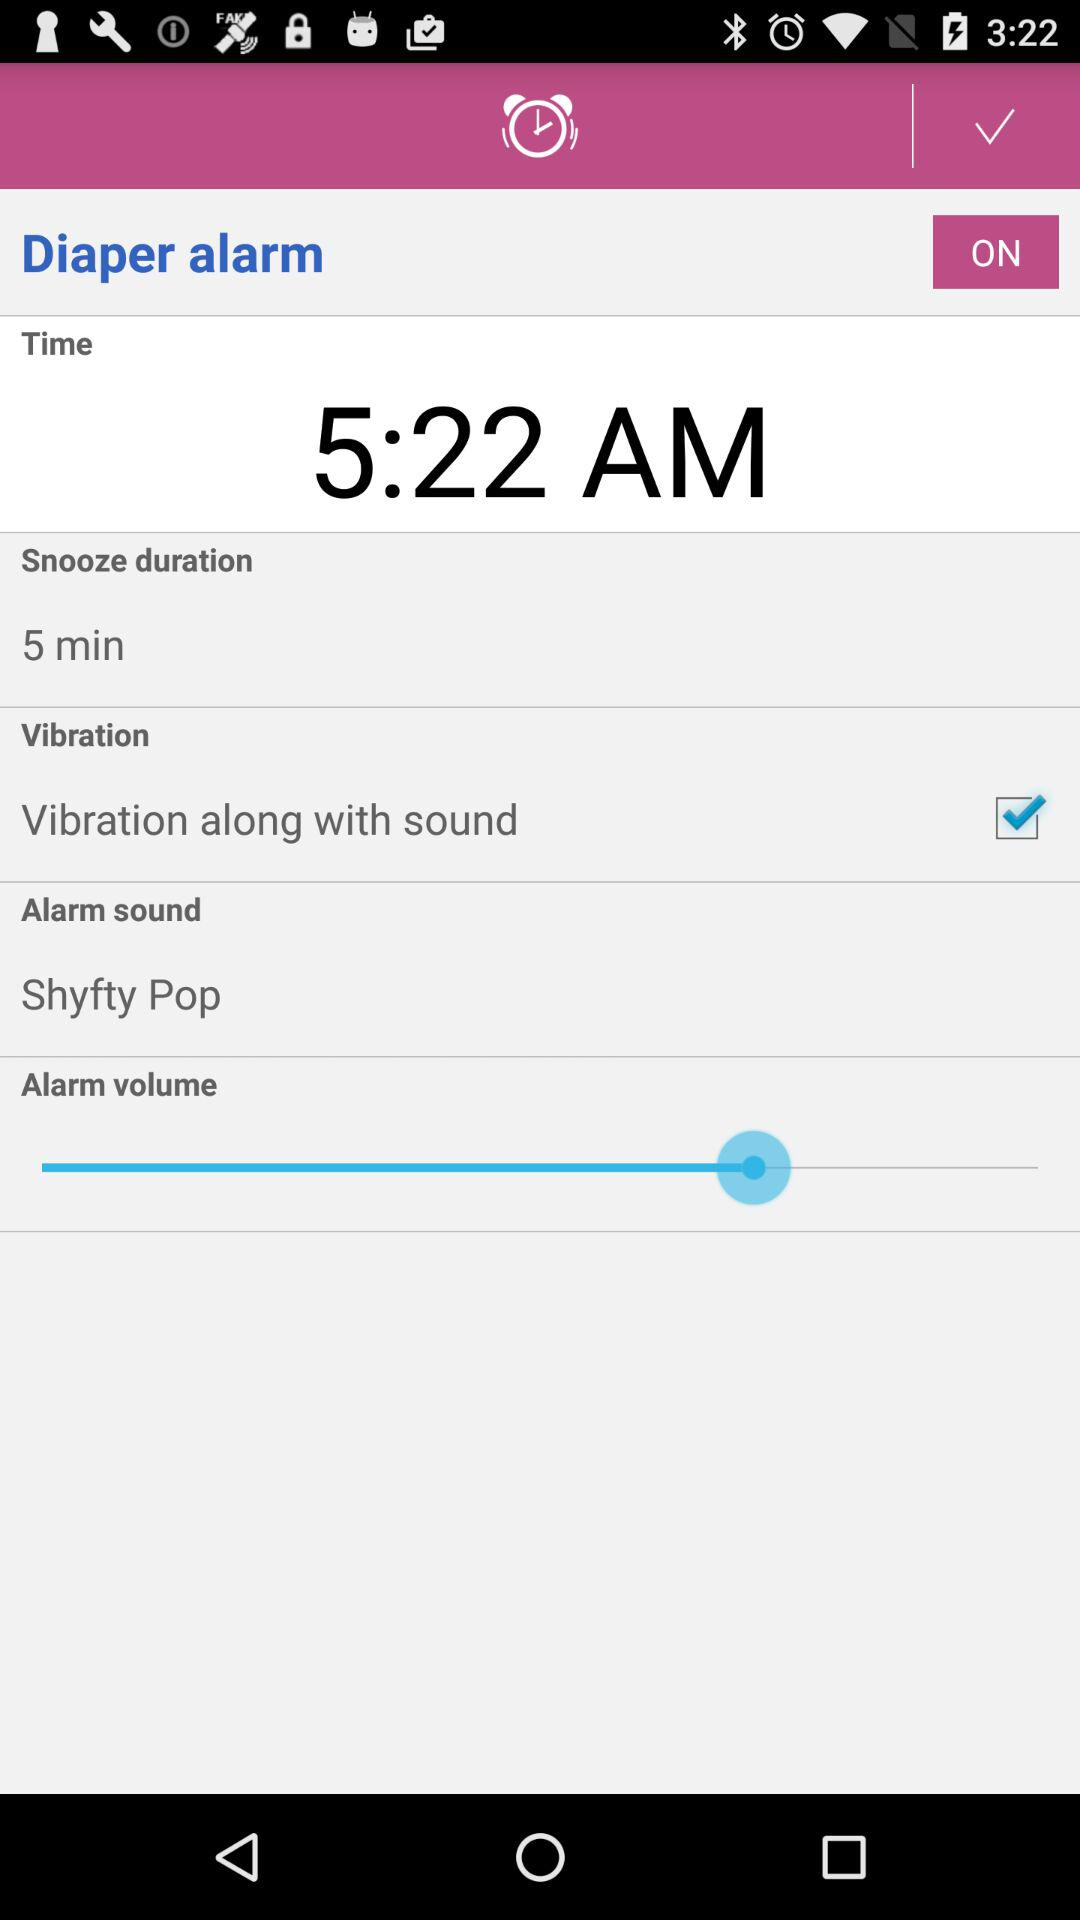What is the alarm time? The alarm time is 5:22 AM. 